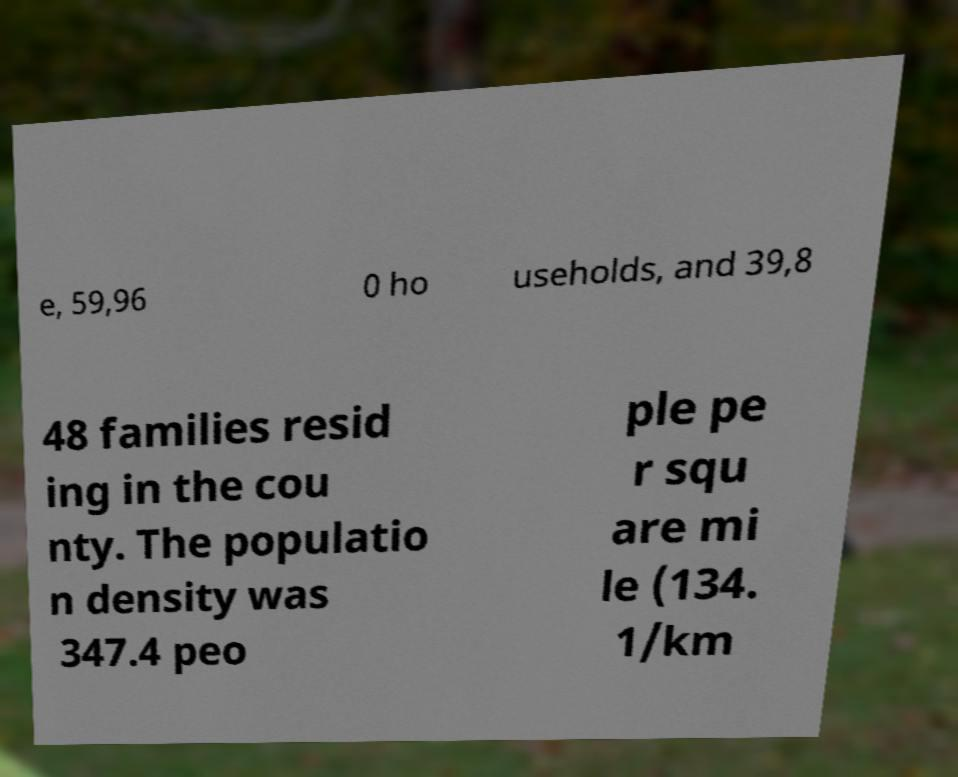Could you assist in decoding the text presented in this image and type it out clearly? e, 59,96 0 ho useholds, and 39,8 48 families resid ing in the cou nty. The populatio n density was 347.4 peo ple pe r squ are mi le (134. 1/km 